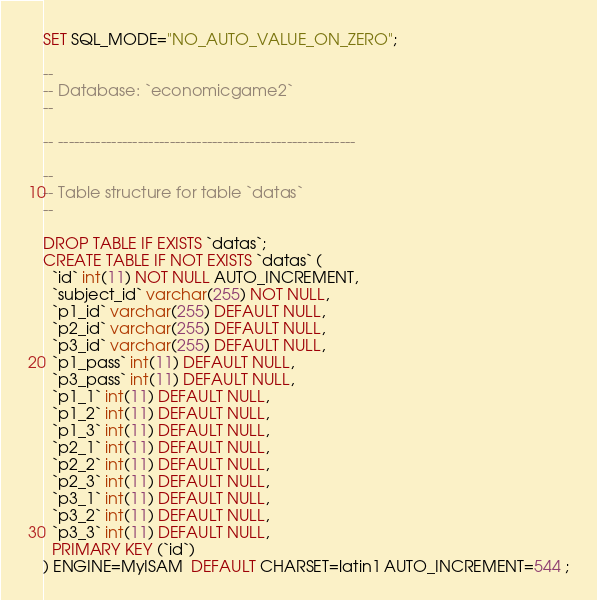<code> <loc_0><loc_0><loc_500><loc_500><_SQL_>SET SQL_MODE="NO_AUTO_VALUE_ON_ZERO";

--
-- Database: `economicgame2`
--

-- --------------------------------------------------------

--
-- Table structure for table `datas`
--

DROP TABLE IF EXISTS `datas`;
CREATE TABLE IF NOT EXISTS `datas` (
  `id` int(11) NOT NULL AUTO_INCREMENT,
  `subject_id` varchar(255) NOT NULL,
  `p1_id` varchar(255) DEFAULT NULL,
  `p2_id` varchar(255) DEFAULT NULL,
  `p3_id` varchar(255) DEFAULT NULL,
  `p1_pass` int(11) DEFAULT NULL,
  `p3_pass` int(11) DEFAULT NULL,
  `p1_1` int(11) DEFAULT NULL,
  `p1_2` int(11) DEFAULT NULL,
  `p1_3` int(11) DEFAULT NULL,
  `p2_1` int(11) DEFAULT NULL,
  `p2_2` int(11) DEFAULT NULL,
  `p2_3` int(11) DEFAULT NULL,
  `p3_1` int(11) DEFAULT NULL,
  `p3_2` int(11) DEFAULT NULL,
  `p3_3` int(11) DEFAULT NULL,
  PRIMARY KEY (`id`)
) ENGINE=MyISAM  DEFAULT CHARSET=latin1 AUTO_INCREMENT=544 ;</code> 